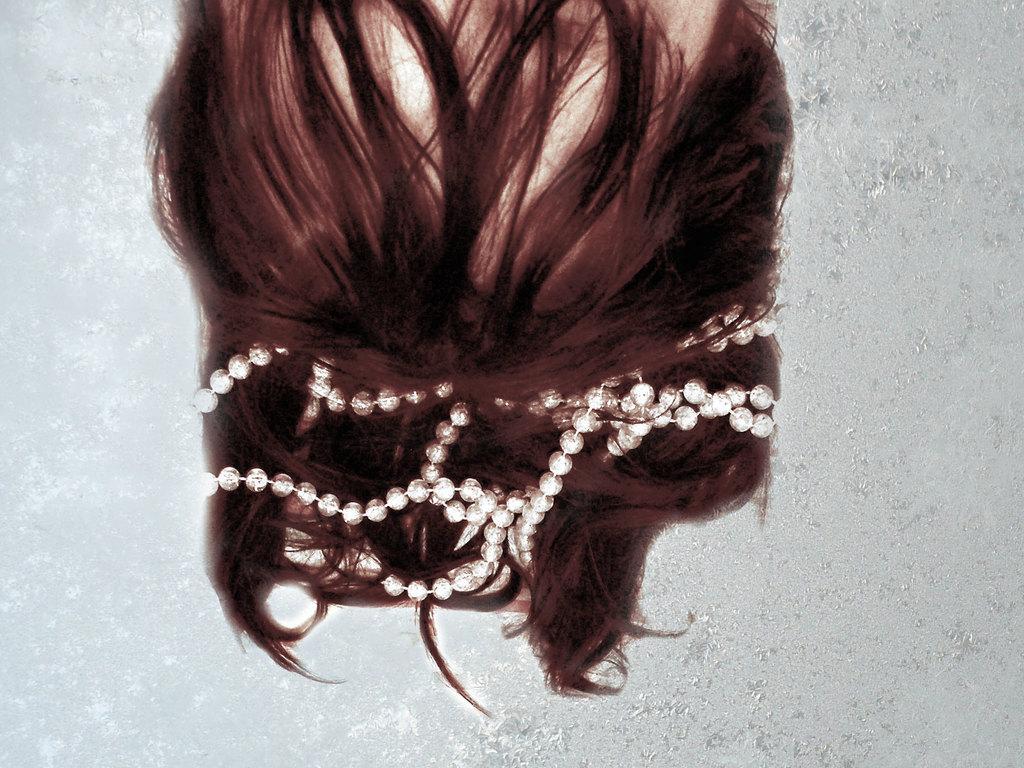Describe this image in one or two sentences. In this picture we can see a person head and on the hair there is a hair accessory. Behind the person, it looks like a wall. 